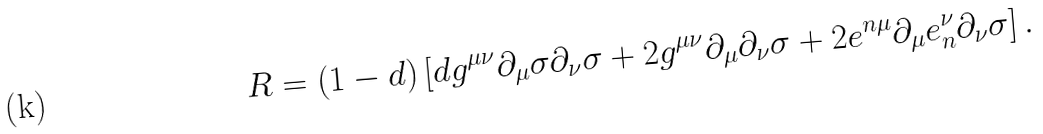<formula> <loc_0><loc_0><loc_500><loc_500>R = \left ( 1 - d \right ) \left [ d g ^ { \mu \nu } \partial _ { \mu } \sigma \partial _ { \nu } \sigma + 2 g ^ { \mu \nu } \partial _ { \mu } \partial _ { \nu } \sigma + 2 e ^ { n \mu } \partial _ { \mu } e _ { n } ^ { \nu } \partial _ { \nu } \sigma \right ] .</formula> 